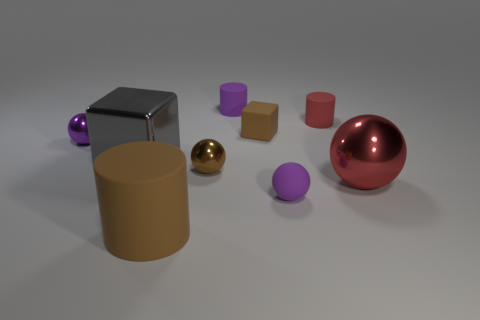Subtract all purple matte cylinders. How many cylinders are left? 2 Subtract all red cylinders. How many purple spheres are left? 2 Subtract all red spheres. How many spheres are left? 3 Subtract all cylinders. How many objects are left? 6 Subtract 2 spheres. How many spheres are left? 2 Add 1 spheres. How many objects exist? 10 Subtract 0 green cylinders. How many objects are left? 9 Subtract all red spheres. Subtract all blue cylinders. How many spheres are left? 3 Subtract all small yellow matte balls. Subtract all purple metal objects. How many objects are left? 8 Add 5 purple balls. How many purple balls are left? 7 